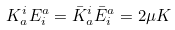Convert formula to latex. <formula><loc_0><loc_0><loc_500><loc_500>K ^ { i } _ { a } E _ { i } ^ { a } = \bar { K } ^ { i } _ { a } \bar { E } _ { i } ^ { a } = 2 \mu K</formula> 